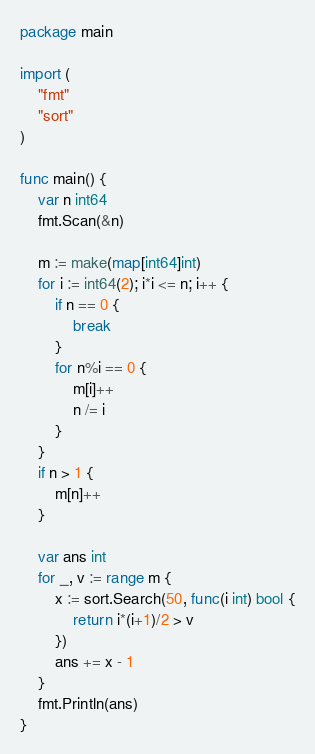<code> <loc_0><loc_0><loc_500><loc_500><_Go_>package main

import (
	"fmt"
	"sort"
)

func main() {
	var n int64
	fmt.Scan(&n)

	m := make(map[int64]int)
	for i := int64(2); i*i <= n; i++ {
		if n == 0 {
			break
		}
		for n%i == 0 {
			m[i]++
			n /= i
		}
	}
	if n > 1 {
		m[n]++
	}

	var ans int
	for _, v := range m {
		x := sort.Search(50, func(i int) bool {
			return i*(i+1)/2 > v
		})
		ans += x - 1
	}
	fmt.Println(ans)
}
</code> 